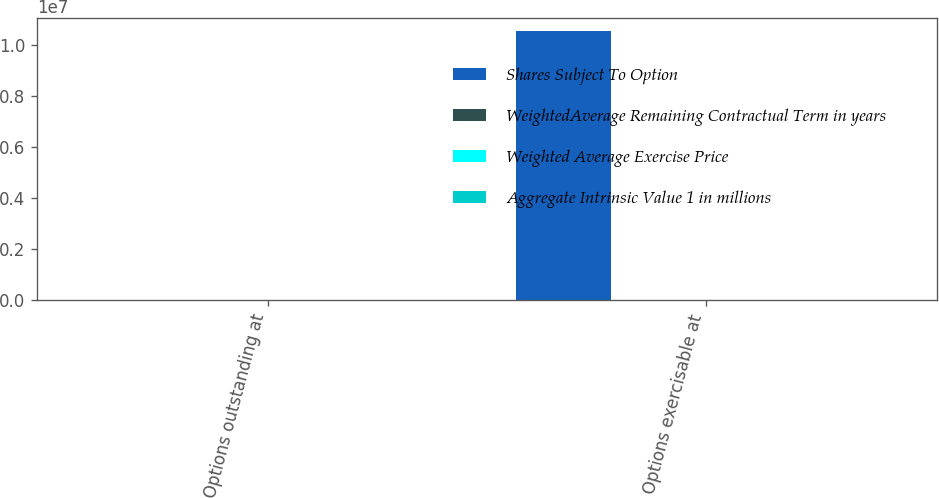Convert chart to OTSL. <chart><loc_0><loc_0><loc_500><loc_500><stacked_bar_chart><ecel><fcel>Options outstanding at<fcel>Options exercisable at<nl><fcel>Shares Subject To Option<fcel>15.13<fcel>1.05471e+07<nl><fcel>WeightedAverage Remaining Contractual Term in years<fcel>15.13<fcel>15.83<nl><fcel>Weighted Average Exercise Price<fcel>6.1<fcel>4<nl><fcel>Aggregate Intrinsic Value 1 in millions<fcel>28.6<fcel>11.9<nl></chart> 